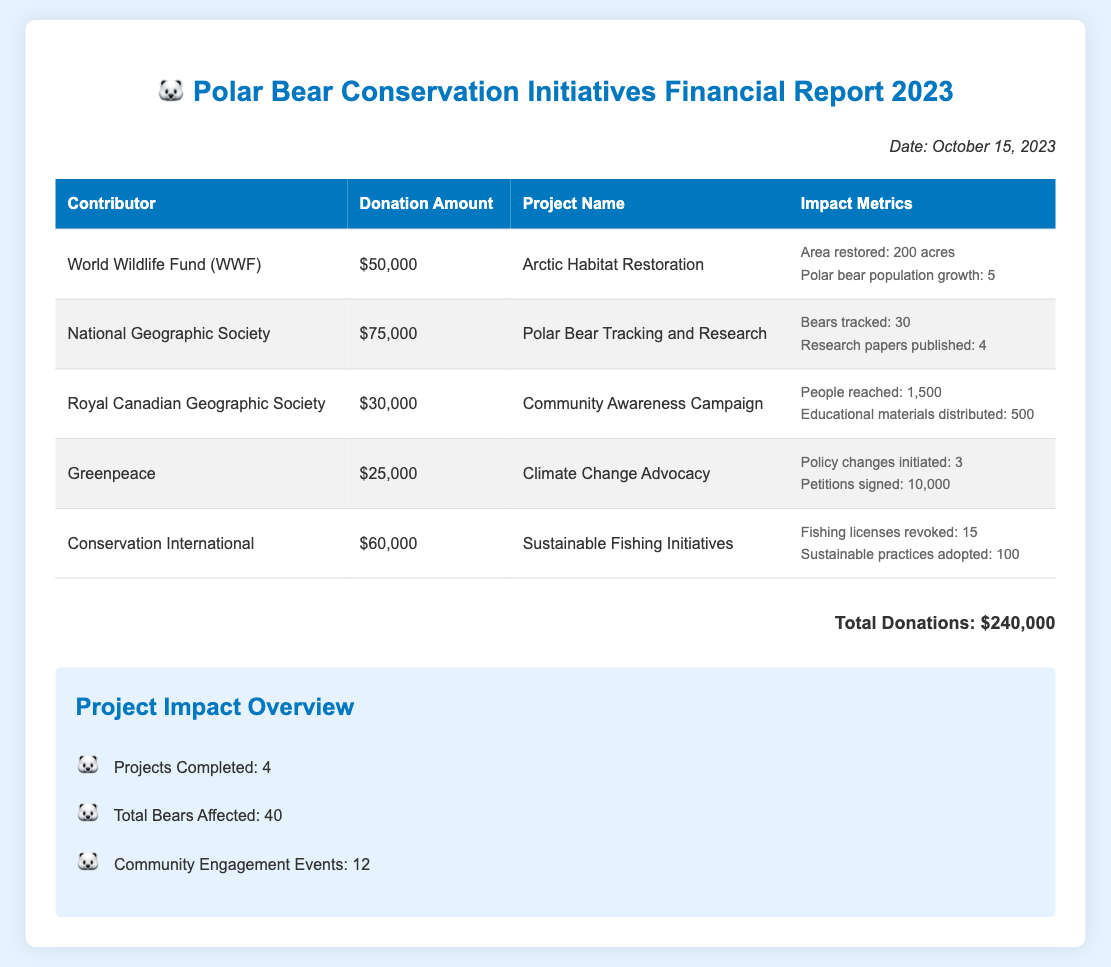what is the total amount of donations received? The total amount of donations is listed at the bottom of the document as the sum of individual contributions.
Answer: $240,000 who contributed the most to the Polar Bear Conservation initiatives? The highest contributor is identified by the donation amounts listed in the table.
Answer: National Geographic Society how many people were reached by the Community Awareness Campaign? The number of people reached is specified in the impact metrics for the corresponding project.
Answer: 1,500 how many educational materials were distributed as part of the Community Awareness Campaign? The document specifies the number of educational materials distributed in the corresponding impact metrics.
Answer: 500 how many projects have been completed as reported in the Project Impact Overview? This number is stated in the Project Impact Overview section of the document.
Answer: 4 which organization engaged in Climate Change Advocacy? The organization involved in this initiative is mentioned in the contributor table.
Answer: Greenpeace what is the area restored in the Arctic Habitat Restoration project? The area restored is indicated in the impact metrics for the specific project.
Answer: 200 acres how many polar bears were tracked in the Polar Bear Tracking and Research project? The document provides this information in the impact metrics for that project.
Answer: 30 how many petitions were signed for Climate Change Advocacy? The number of petitions is detailed in the impact metrics for that initiative.
Answer: 10,000 